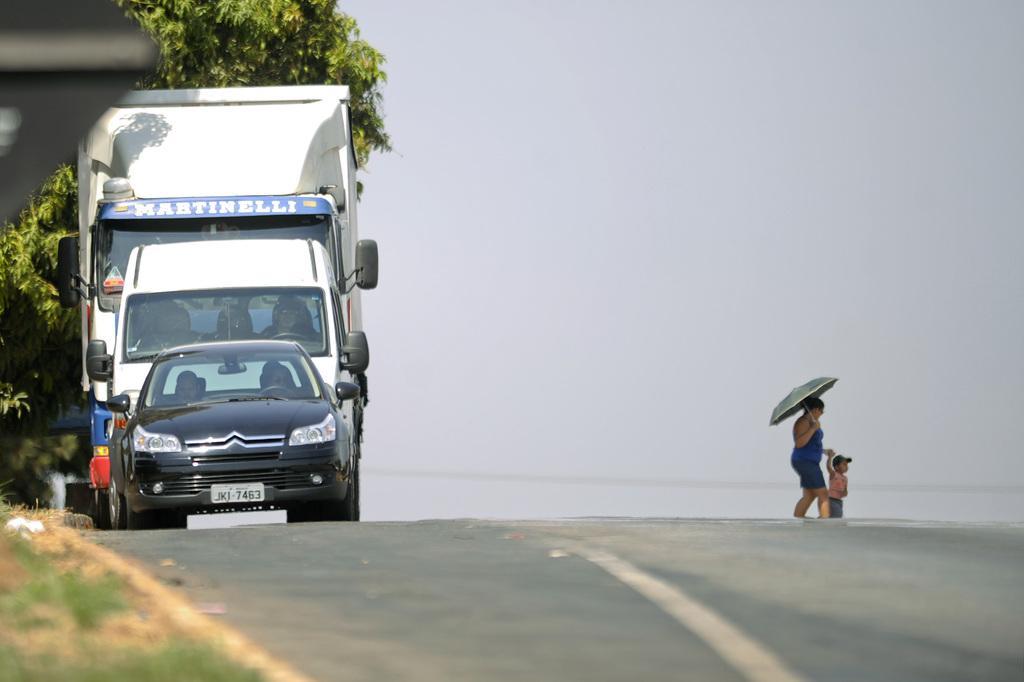In one or two sentences, can you explain what this image depicts? At the left bottom of the image there is grass on the ground. And in the middle of the image there is a road. On the road to the left side there is a black car. Behind the car there is a truck. Behind the truck there is a tree. On the road to the right side there is a lady with blue dress is walking and also she is holding the kid in her hand. And in the background there is a sky. 